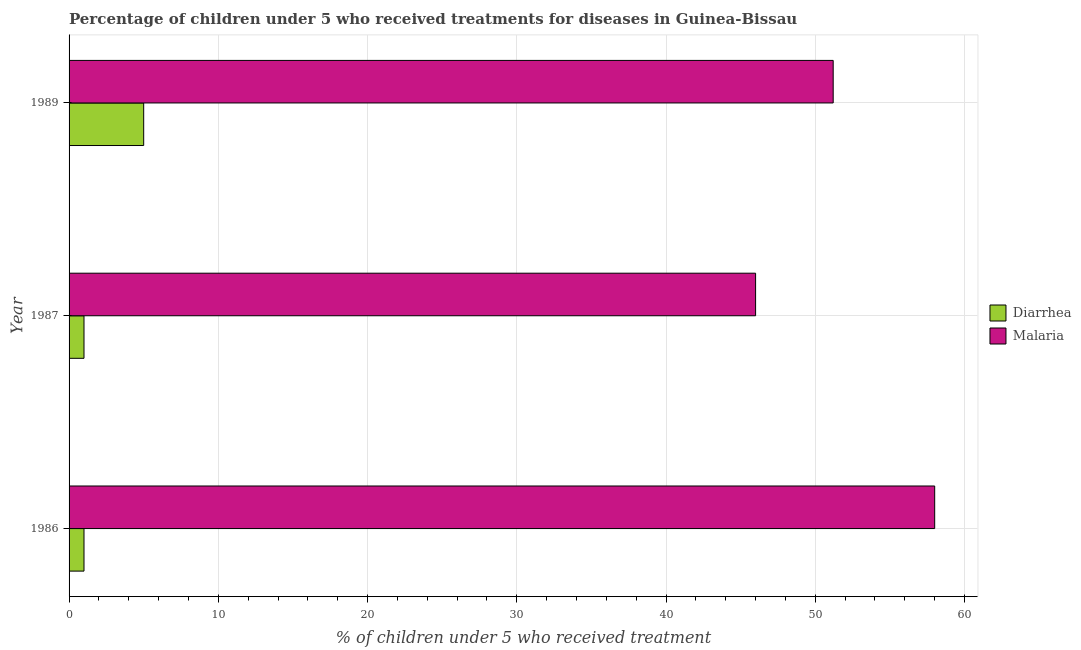Are the number of bars per tick equal to the number of legend labels?
Offer a terse response. Yes. Are the number of bars on each tick of the Y-axis equal?
Provide a succinct answer. Yes. How many bars are there on the 2nd tick from the bottom?
Provide a succinct answer. 2. What is the label of the 2nd group of bars from the top?
Provide a short and direct response. 1987. In how many cases, is the number of bars for a given year not equal to the number of legend labels?
Your answer should be compact. 0. What is the percentage of children who received treatment for malaria in 1986?
Provide a succinct answer. 58. Across all years, what is the maximum percentage of children who received treatment for diarrhoea?
Your response must be concise. 5. Across all years, what is the minimum percentage of children who received treatment for malaria?
Offer a terse response. 46. In which year was the percentage of children who received treatment for malaria maximum?
Your answer should be very brief. 1986. In which year was the percentage of children who received treatment for diarrhoea minimum?
Your answer should be very brief. 1986. What is the total percentage of children who received treatment for malaria in the graph?
Provide a short and direct response. 155.2. What is the difference between the percentage of children who received treatment for diarrhoea in 1986 and that in 1989?
Give a very brief answer. -4. What is the difference between the percentage of children who received treatment for diarrhoea in 1987 and the percentage of children who received treatment for malaria in 1986?
Provide a succinct answer. -57. What is the average percentage of children who received treatment for diarrhoea per year?
Offer a terse response. 2.33. What is the ratio of the percentage of children who received treatment for malaria in 1986 to that in 1987?
Provide a succinct answer. 1.26. Is the percentage of children who received treatment for malaria in 1986 less than that in 1989?
Your answer should be very brief. No. What is the difference between the highest and the lowest percentage of children who received treatment for diarrhoea?
Your response must be concise. 4. In how many years, is the percentage of children who received treatment for malaria greater than the average percentage of children who received treatment for malaria taken over all years?
Your answer should be very brief. 1. What does the 1st bar from the top in 1987 represents?
Your response must be concise. Malaria. What does the 1st bar from the bottom in 1986 represents?
Keep it short and to the point. Diarrhea. How many years are there in the graph?
Give a very brief answer. 3. Are the values on the major ticks of X-axis written in scientific E-notation?
Your answer should be compact. No. Does the graph contain grids?
Your answer should be compact. Yes. Where does the legend appear in the graph?
Offer a terse response. Center right. How are the legend labels stacked?
Give a very brief answer. Vertical. What is the title of the graph?
Offer a terse response. Percentage of children under 5 who received treatments for diseases in Guinea-Bissau. Does "From human activities" appear as one of the legend labels in the graph?
Ensure brevity in your answer.  No. What is the label or title of the X-axis?
Provide a short and direct response. % of children under 5 who received treatment. What is the % of children under 5 who received treatment in Diarrhea in 1986?
Offer a terse response. 1. What is the % of children under 5 who received treatment in Diarrhea in 1989?
Provide a short and direct response. 5. What is the % of children under 5 who received treatment of Malaria in 1989?
Provide a succinct answer. 51.2. What is the total % of children under 5 who received treatment of Malaria in the graph?
Offer a very short reply. 155.2. What is the difference between the % of children under 5 who received treatment of Malaria in 1986 and that in 1987?
Your response must be concise. 12. What is the difference between the % of children under 5 who received treatment in Malaria in 1986 and that in 1989?
Ensure brevity in your answer.  6.8. What is the difference between the % of children under 5 who received treatment of Malaria in 1987 and that in 1989?
Your answer should be very brief. -5.2. What is the difference between the % of children under 5 who received treatment in Diarrhea in 1986 and the % of children under 5 who received treatment in Malaria in 1987?
Your response must be concise. -45. What is the difference between the % of children under 5 who received treatment of Diarrhea in 1986 and the % of children under 5 who received treatment of Malaria in 1989?
Keep it short and to the point. -50.2. What is the difference between the % of children under 5 who received treatment of Diarrhea in 1987 and the % of children under 5 who received treatment of Malaria in 1989?
Offer a terse response. -50.2. What is the average % of children under 5 who received treatment of Diarrhea per year?
Offer a terse response. 2.33. What is the average % of children under 5 who received treatment of Malaria per year?
Offer a very short reply. 51.73. In the year 1986, what is the difference between the % of children under 5 who received treatment of Diarrhea and % of children under 5 who received treatment of Malaria?
Provide a succinct answer. -57. In the year 1987, what is the difference between the % of children under 5 who received treatment in Diarrhea and % of children under 5 who received treatment in Malaria?
Your answer should be very brief. -45. In the year 1989, what is the difference between the % of children under 5 who received treatment in Diarrhea and % of children under 5 who received treatment in Malaria?
Provide a short and direct response. -46.2. What is the ratio of the % of children under 5 who received treatment of Malaria in 1986 to that in 1987?
Keep it short and to the point. 1.26. What is the ratio of the % of children under 5 who received treatment of Diarrhea in 1986 to that in 1989?
Your answer should be very brief. 0.2. What is the ratio of the % of children under 5 who received treatment in Malaria in 1986 to that in 1989?
Your answer should be very brief. 1.13. What is the ratio of the % of children under 5 who received treatment in Diarrhea in 1987 to that in 1989?
Your answer should be very brief. 0.2. What is the ratio of the % of children under 5 who received treatment of Malaria in 1987 to that in 1989?
Provide a succinct answer. 0.9. What is the difference between the highest and the second highest % of children under 5 who received treatment in Diarrhea?
Your answer should be compact. 4. What is the difference between the highest and the second highest % of children under 5 who received treatment of Malaria?
Offer a very short reply. 6.8. What is the difference between the highest and the lowest % of children under 5 who received treatment in Diarrhea?
Make the answer very short. 4. 